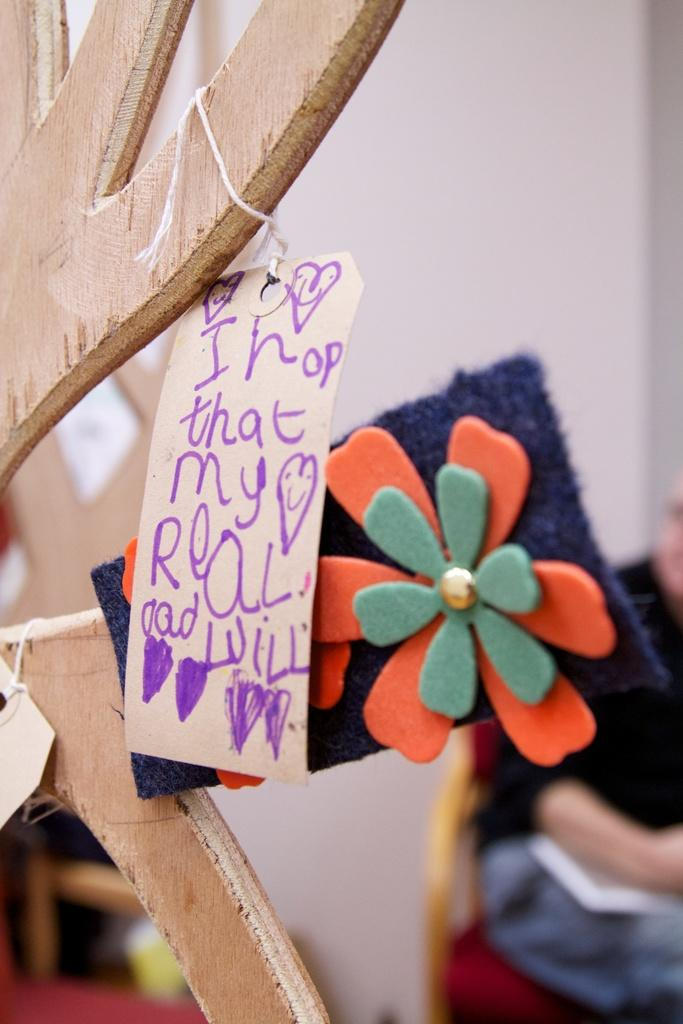What is the stick with a board used for in the image? The stick with a board is not explicitly used for anything in the image, but it is present. What is the design on the cloth in the image? The cloth in the image has a flower design. What is the person in the image doing? The person in the image is sitting on a chair. What can be seen behind the person in the image? There is a wall visible in the image. Is there a hall where the party is taking place in the image? There is no mention of a hall or party in the image; it only shows a stick with a board, a cloth with a flower design, a person sitting on a chair, and a wall. Can you see the person's self in the image? The image does not show a reflection or any indication of the person's self; it only shows the person sitting on a chair. 